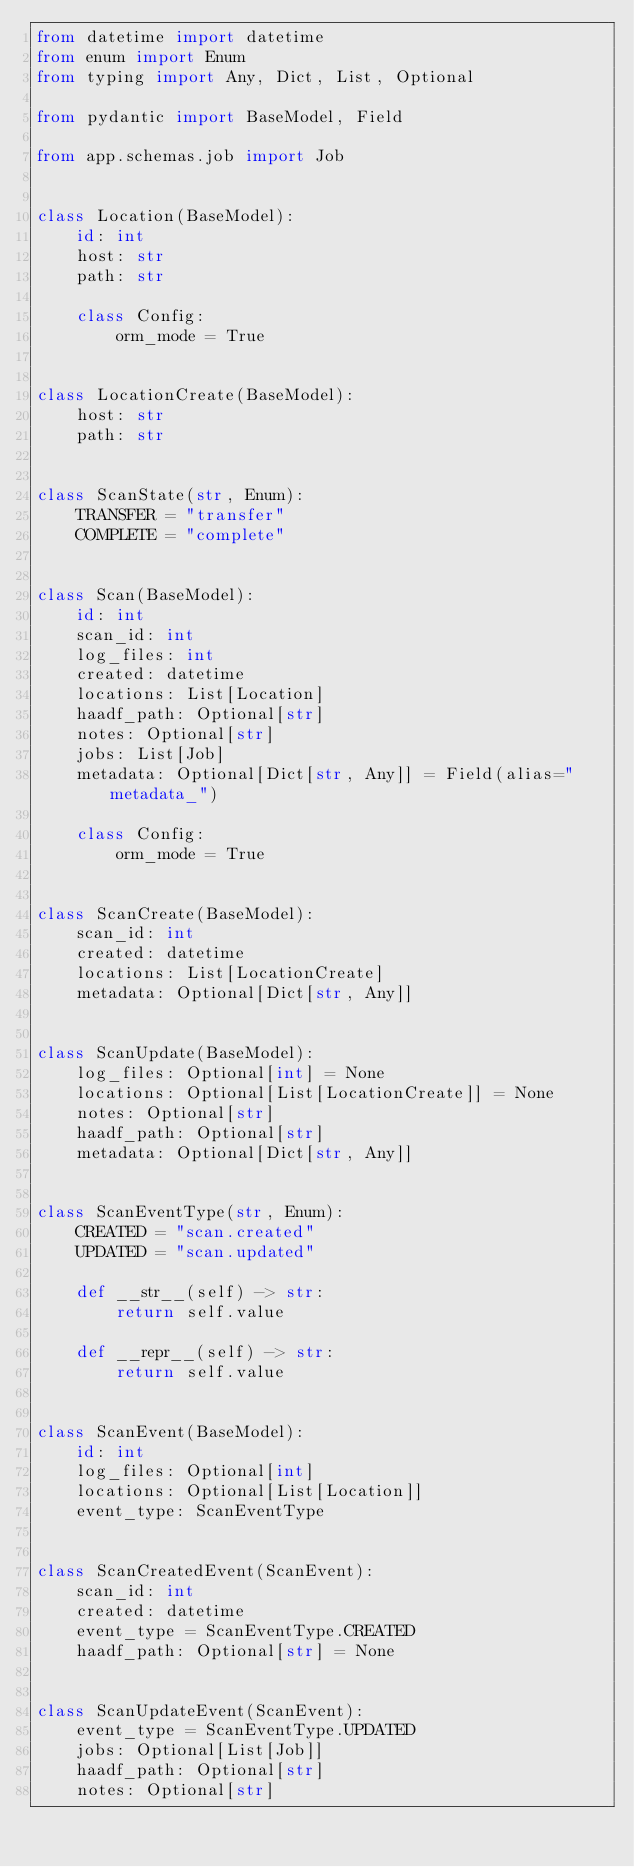<code> <loc_0><loc_0><loc_500><loc_500><_Python_>from datetime import datetime
from enum import Enum
from typing import Any, Dict, List, Optional

from pydantic import BaseModel, Field

from app.schemas.job import Job


class Location(BaseModel):
    id: int
    host: str
    path: str

    class Config:
        orm_mode = True


class LocationCreate(BaseModel):
    host: str
    path: str


class ScanState(str, Enum):
    TRANSFER = "transfer"
    COMPLETE = "complete"


class Scan(BaseModel):
    id: int
    scan_id: int
    log_files: int
    created: datetime
    locations: List[Location]
    haadf_path: Optional[str]
    notes: Optional[str]
    jobs: List[Job]
    metadata: Optional[Dict[str, Any]] = Field(alias="metadata_")

    class Config:
        orm_mode = True


class ScanCreate(BaseModel):
    scan_id: int
    created: datetime
    locations: List[LocationCreate]
    metadata: Optional[Dict[str, Any]]


class ScanUpdate(BaseModel):
    log_files: Optional[int] = None
    locations: Optional[List[LocationCreate]] = None
    notes: Optional[str]
    haadf_path: Optional[str]
    metadata: Optional[Dict[str, Any]]


class ScanEventType(str, Enum):
    CREATED = "scan.created"
    UPDATED = "scan.updated"

    def __str__(self) -> str:
        return self.value

    def __repr__(self) -> str:
        return self.value


class ScanEvent(BaseModel):
    id: int
    log_files: Optional[int]
    locations: Optional[List[Location]]
    event_type: ScanEventType


class ScanCreatedEvent(ScanEvent):
    scan_id: int
    created: datetime
    event_type = ScanEventType.CREATED
    haadf_path: Optional[str] = None


class ScanUpdateEvent(ScanEvent):
    event_type = ScanEventType.UPDATED
    jobs: Optional[List[Job]]
    haadf_path: Optional[str]
    notes: Optional[str]
</code> 